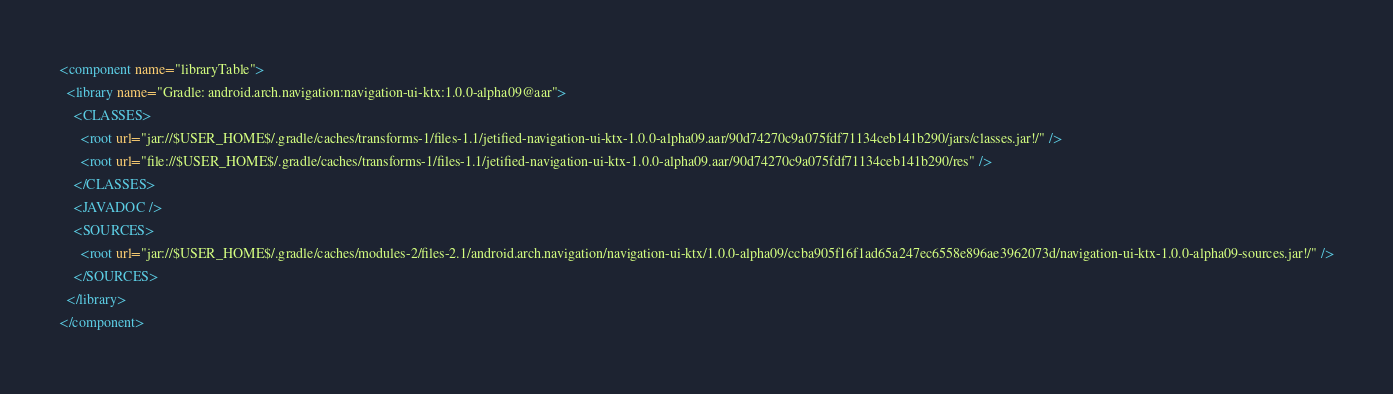Convert code to text. <code><loc_0><loc_0><loc_500><loc_500><_XML_><component name="libraryTable">
  <library name="Gradle: android.arch.navigation:navigation-ui-ktx:1.0.0-alpha09@aar">
    <CLASSES>
      <root url="jar://$USER_HOME$/.gradle/caches/transforms-1/files-1.1/jetified-navigation-ui-ktx-1.0.0-alpha09.aar/90d74270c9a075fdf71134ceb141b290/jars/classes.jar!/" />
      <root url="file://$USER_HOME$/.gradle/caches/transforms-1/files-1.1/jetified-navigation-ui-ktx-1.0.0-alpha09.aar/90d74270c9a075fdf71134ceb141b290/res" />
    </CLASSES>
    <JAVADOC />
    <SOURCES>
      <root url="jar://$USER_HOME$/.gradle/caches/modules-2/files-2.1/android.arch.navigation/navigation-ui-ktx/1.0.0-alpha09/ccba905f16f1ad65a247ec6558e896ae3962073d/navigation-ui-ktx-1.0.0-alpha09-sources.jar!/" />
    </SOURCES>
  </library>
</component></code> 